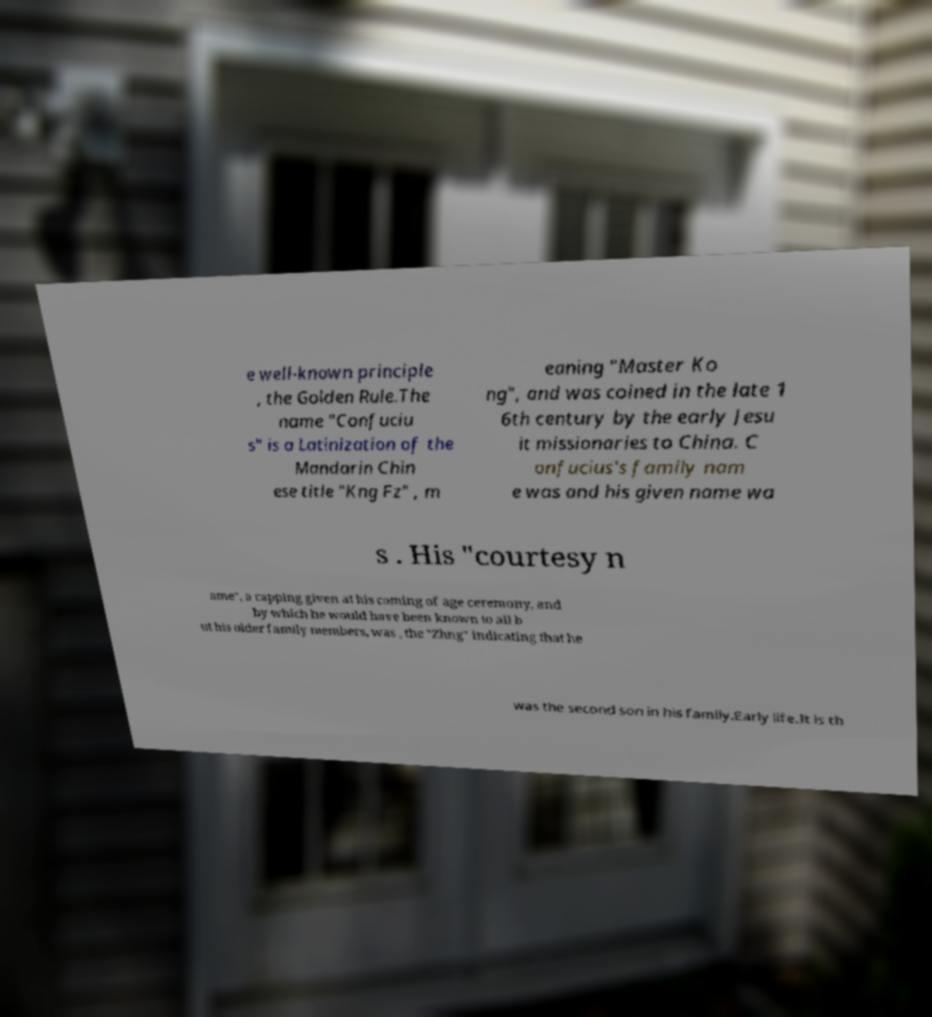Could you assist in decoding the text presented in this image and type it out clearly? e well-known principle , the Golden Rule.The name "Confuciu s" is a Latinization of the Mandarin Chin ese title "Kng Fz" , m eaning "Master Ko ng", and was coined in the late 1 6th century by the early Jesu it missionaries to China. C onfucius's family nam e was and his given name wa s . His "courtesy n ame", a capping given at his coming of age ceremony, and by which he would have been known to all b ut his older family members, was , the "Zhng" indicating that he was the second son in his family.Early life.It is th 